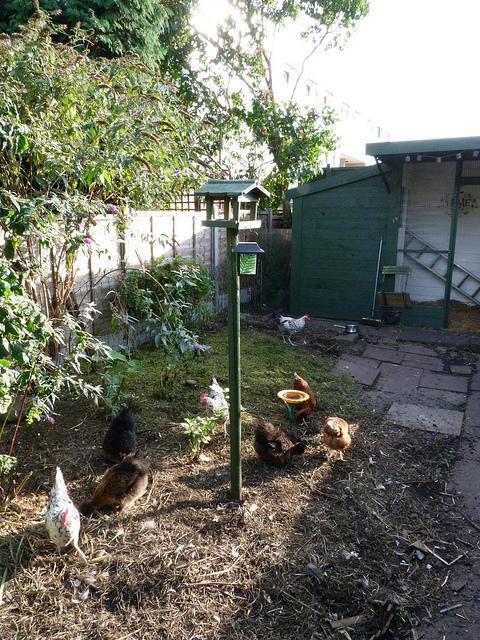How many sheep with horns are on the picture?
Give a very brief answer. 0. 